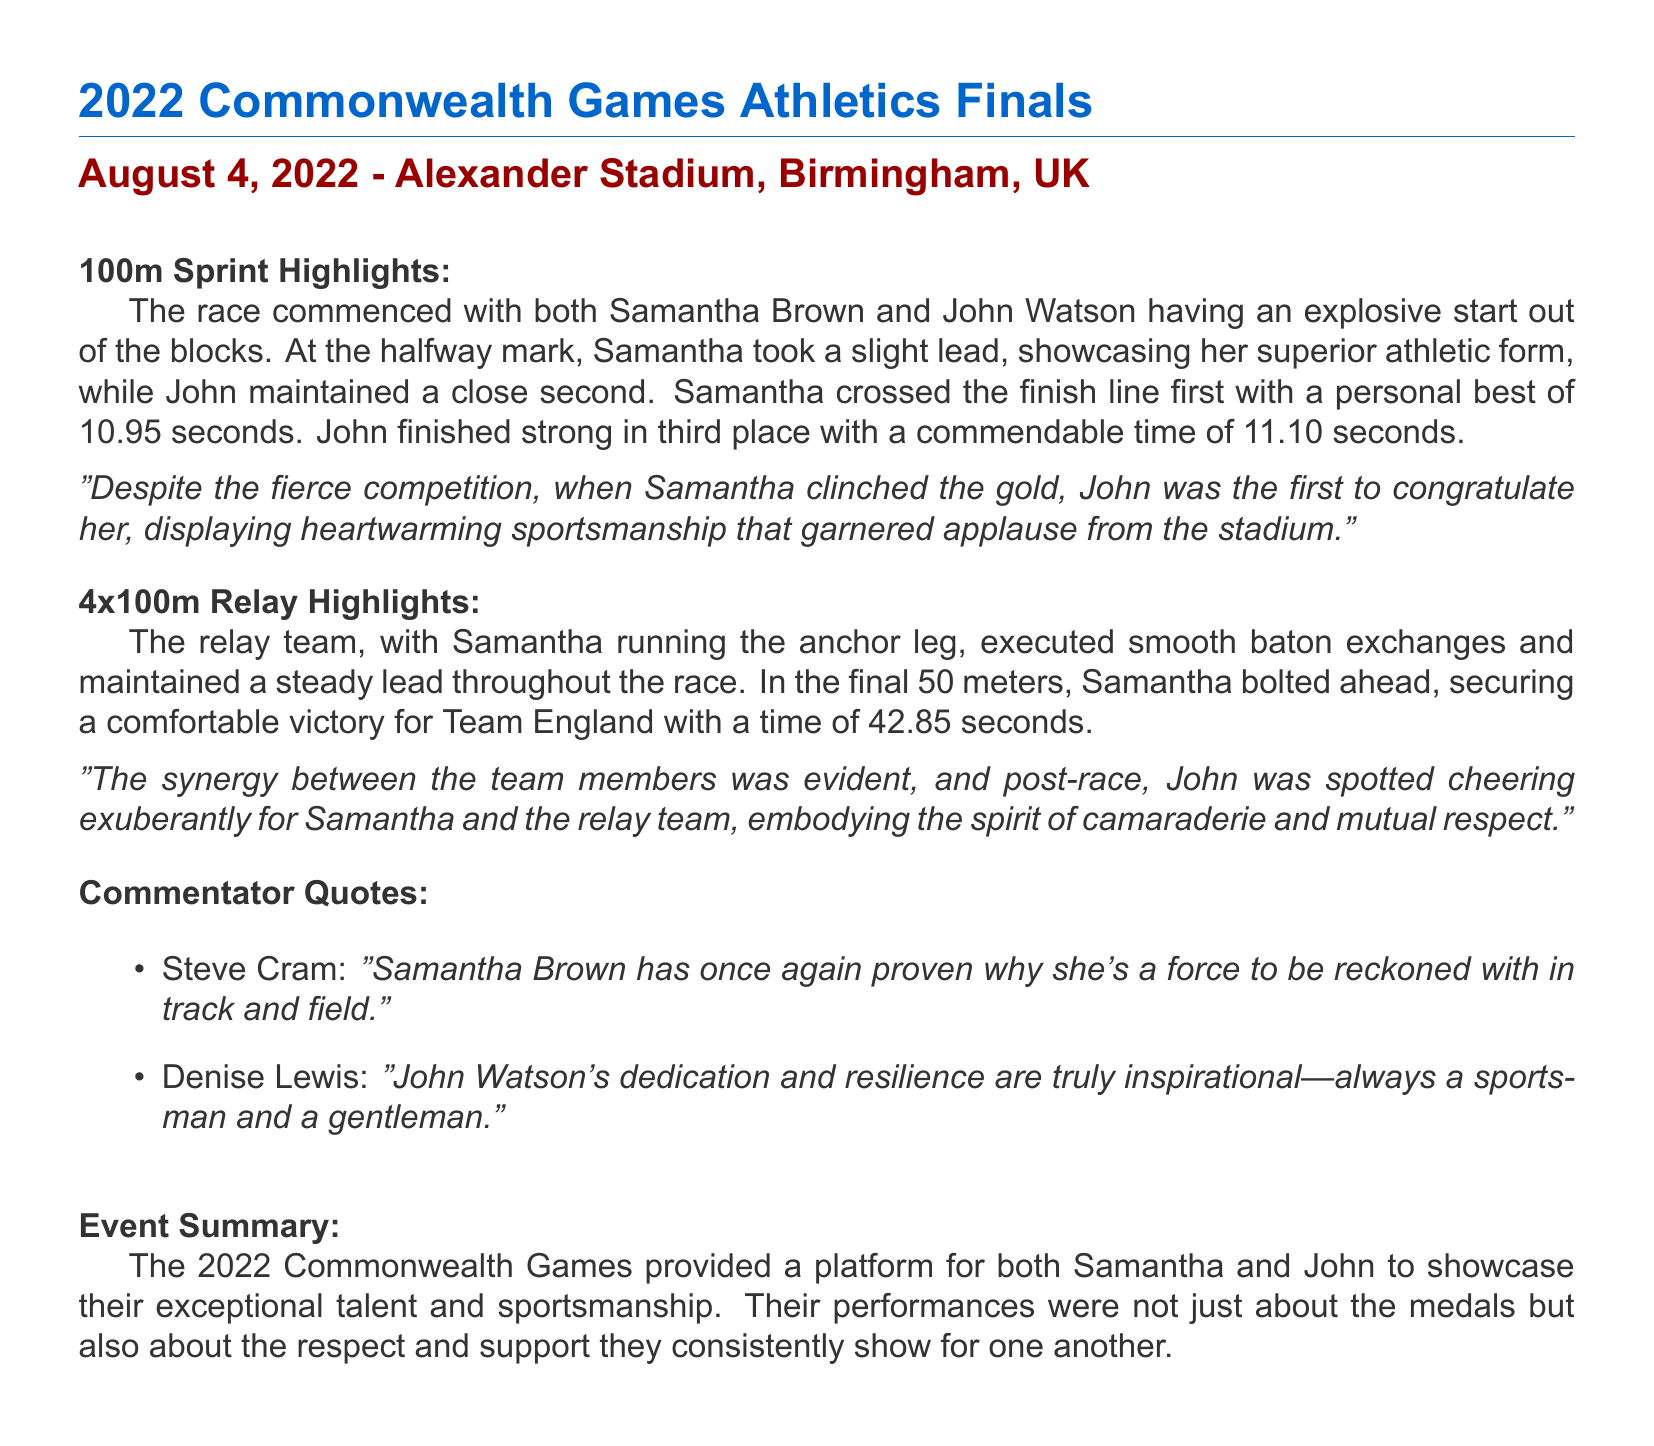What is the date of the event? The event took place on August 4, 2022, as stated in the document.
Answer: August 4, 2022 Who finished first in the 100m sprint? The document indicates that Samantha Brown finished first in the race.
Answer: Samantha Brown What was John's time in the 100m sprint? John's finishing time in the 100m sprint is mentioned as 11.10 seconds.
Answer: 11.10 seconds What position did John finish in the 100m sprint? The document indicates that John finished in third place during the sprint.
Answer: Third place What was the relay team's time in the 4x100m relay? The document states that the relay team's time was 42.85 seconds.
Answer: 42.85 seconds Who ran the anchor leg in the 4x100m relay? The document specifies that Samantha ran the anchor leg for her team.
Answer: Samantha What does Steve Cram say about Samantha? Steve Cram stated that Samantha has proven to be a force to be reckoned with.
Answer: A force to be reckoned with How did John show sportsmanship after the 100m sprint? John congratulated Samantha first after her victory, showing heartwarming sportsmanship.
Answer: Congratulated her first What do both athletes showcase through their performances? The document highlights that both athletes showcase exceptional talent and sportsmanship.
Answer: Exceptional talent and sportsmanship 